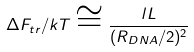<formula> <loc_0><loc_0><loc_500><loc_500>\Delta F _ { t r } / k T \cong \frac { l L } { ( R _ { D N A } / 2 ) ^ { 2 } }</formula> 